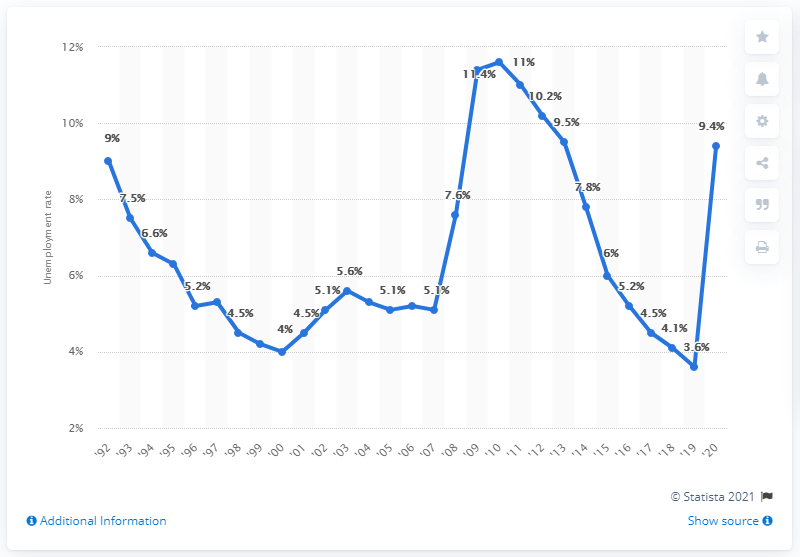Outline some significant characteristics in this image. The unemployment rate in Rhode Island in 2020 was 9.4%. In 2010, Rhode Island had the highest unemployment rate at 11.6%. In 2010, the unemployment rate in Rhode Island was 3.6%. 